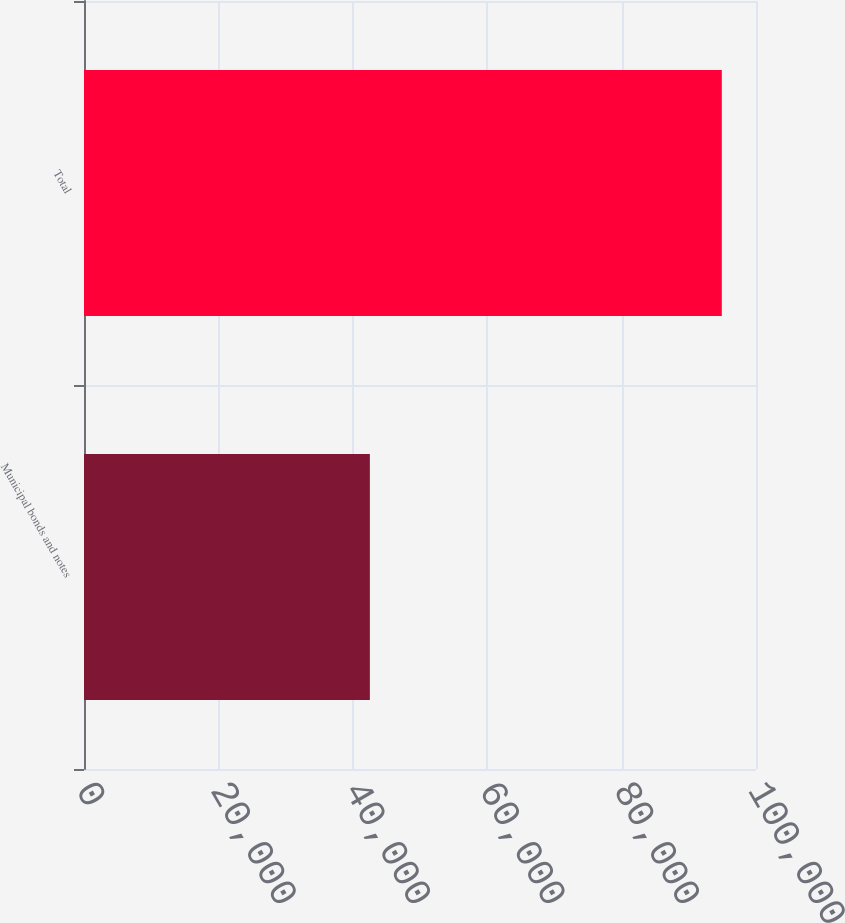<chart> <loc_0><loc_0><loc_500><loc_500><bar_chart><fcel>Municipal bonds and notes<fcel>Total<nl><fcel>42541<fcel>94911<nl></chart> 